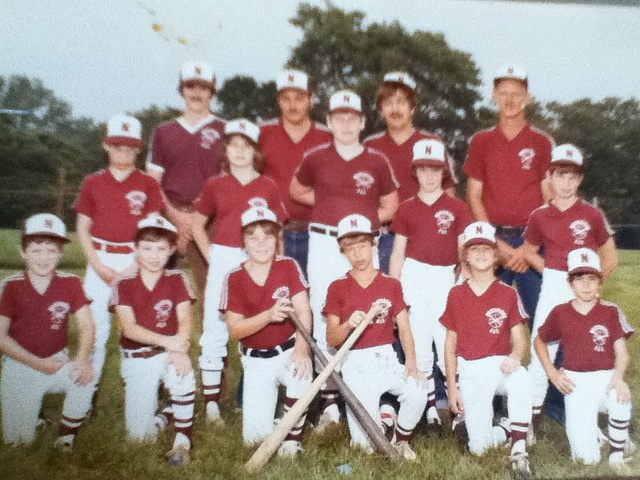Describe the objects in this image and their specific colors. I can see people in lightblue, brown, and salmon tones, people in lightblue, lightgray, darkgray, and brown tones, people in lightblue, darkgray, maroon, and gray tones, people in lightblue, lightgray, brown, tan, and darkgray tones, and people in lightblue, lightgray, brown, tan, and darkgray tones in this image. 